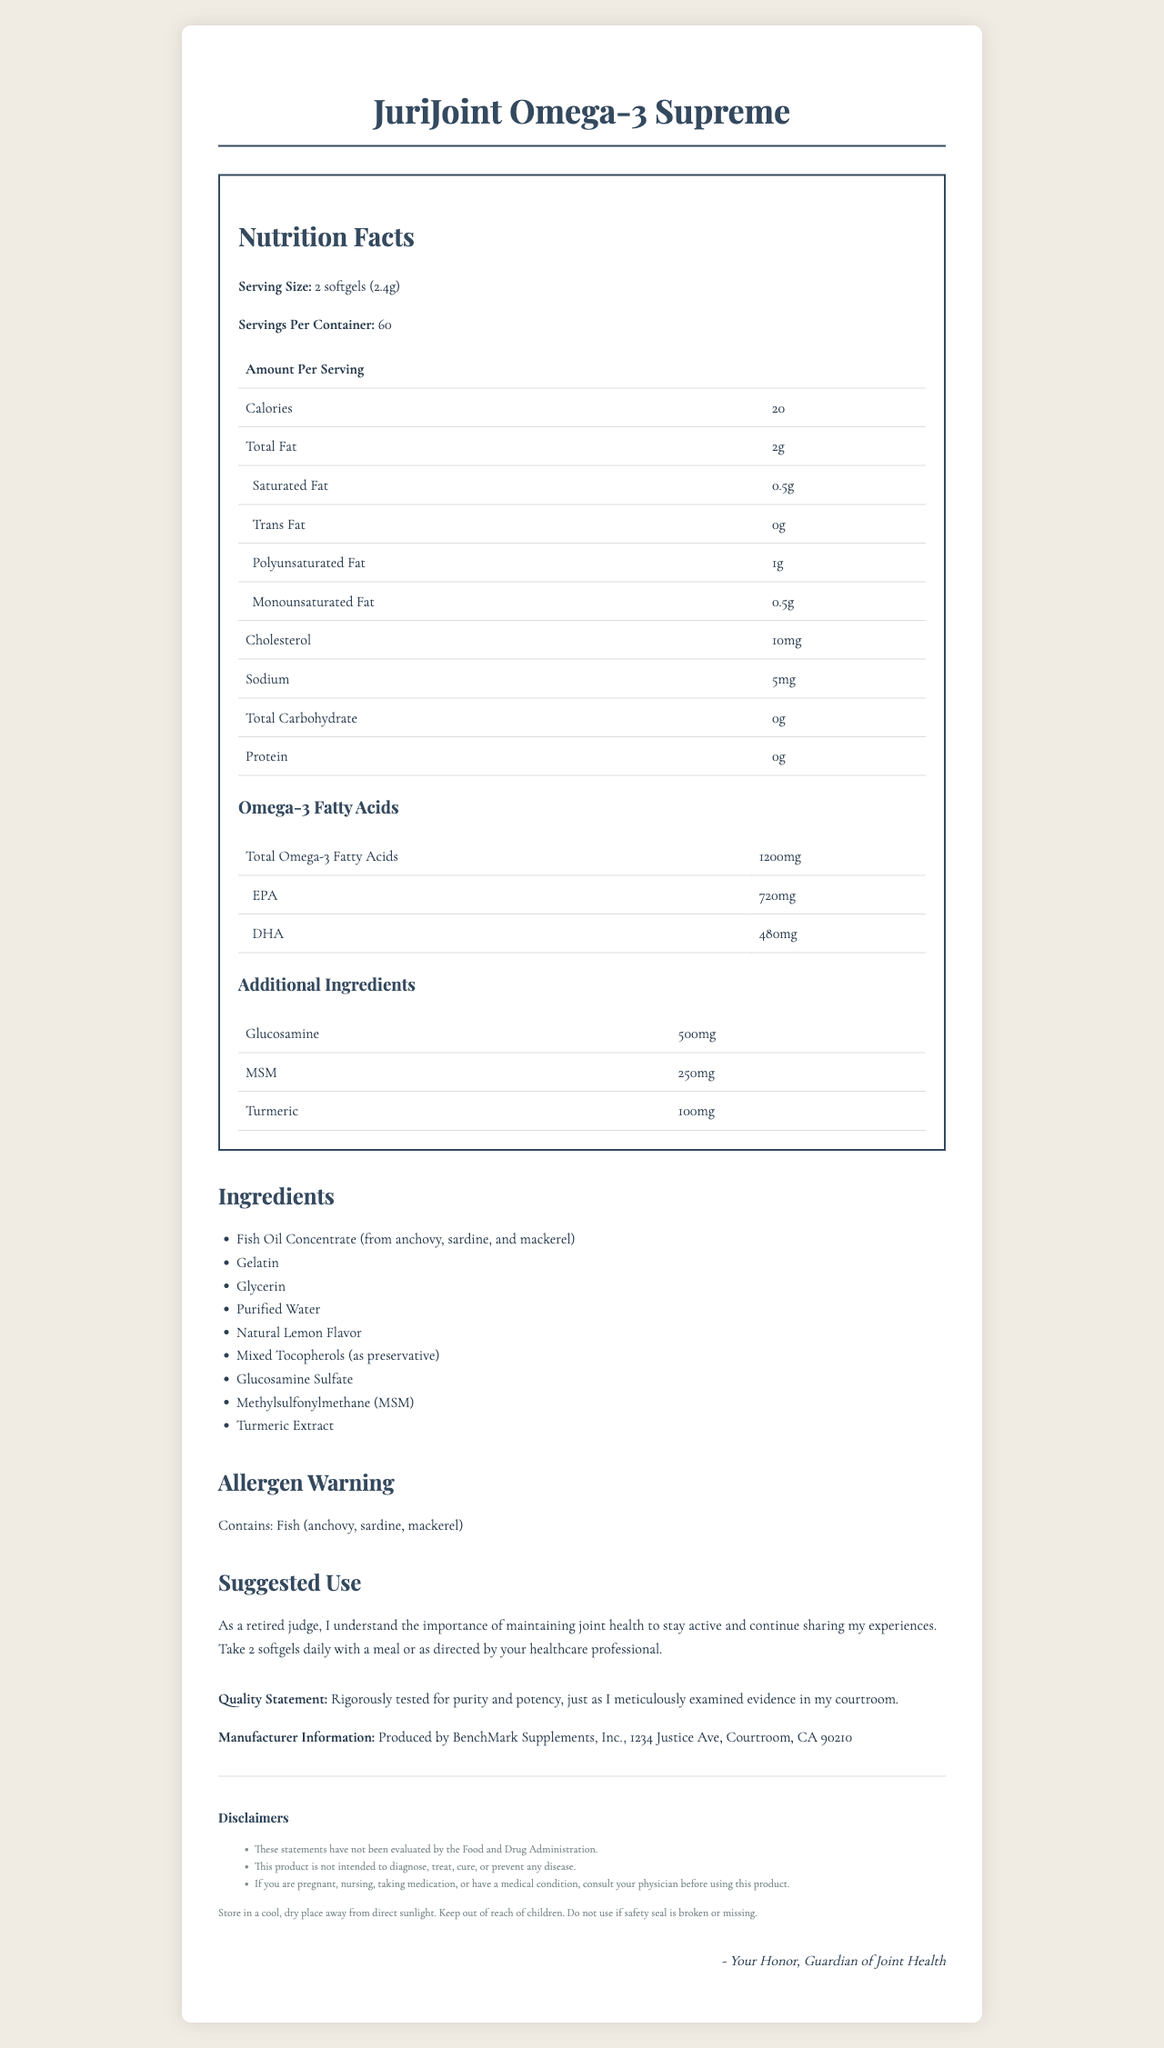what is the serving size? The serving size is mentioned at the beginning of the Nutrition Facts section.
Answer: 2 softgels (2.4g) what allergens are present in this supplement? The allergens are indicated in the "Allergen Warning" section.
Answer: Fish (anchovy, sardine, mackerel) how many calories are in one serving? It is listed under the "Amount Per Serving" in the Nutrition Facts section.
Answer: 20 calories which ingredient is present in the highest amount among omega-3 fatty acids? A. EPA B. DHA C. Other Omega-3s EPA has 720mg, DHA has 480mg, and there is 0mg for other Omega-3s.
Answer: A. EPA what is the suggested usage for this supplement? The suggested usage is clearly stated in the "Suggested Use" section.
Answer: Take 2 softgels daily with a meal or as directed by your healthcare professional. does this product contain any protein? The total protein content is listed as 0g in the Nutrition Facts table.
Answer: No what are the key active ingredients besides omega-3s? Listed in the Additional Ingredients table: Glucosamine (500mg), MSM (250mg), Turmeric (100mg).
Answer: Glucosamine, MSM, Turmeric what is the manufacturer's address? This information is provided in the "Manufacturer Information" section.
Answer: 1234 Justice Ave, Courtroom, CA 90210 which type of fat is present in the lowest amount? A. Saturated Fat B. Monounsaturated Fat C. Polyunsaturated Fat The document lists Saturated Fat as 0.5g, Monounsaturated Fat as 0.5g, and Polyunsaturated Fat as 1g.
Answer: C. Polyunsaturated Fat Are there any carbohydrates in JuriJoint Omega-3 Supreme? Total Carbohydrates is listed as 0g in the Nutrition Facts table.
Answer: No what is the purpose of this supplement? Based on the product name and the ingredients such as omega-3 fatty acids, glucosamine, MSM, and turmeric, the supplement is designed for joint health and reducing inflammation.
Answer: To support joint health and reduce inflammation does the product contain any vitamin D? The Vitamin D content is listed as 0mcg in the Nutrition Facts table.
Answer: No summarize the main idea of the document. The document presents comprehensive nutritional data, ingredient lists, usage instructions, and additional label information for the JuriJoint Omega-3 Supreme supplement, emphasizing its benefits and compliance with quality standards.
Answer: JuriJoint Omega-3 Supreme is a fish oil supplement rich in omega-3 fatty acids, glucosamine, MSM, and turmeric, designed to support joint health and reduce inflammation. It provides detailed nutritional information, ingredients, allergen warnings, suggested usage, and manufacturer details while stressing the product's purity and potency. how many different types of fish are used in the fish oil concentrate? The ingredients list shows that the fish oil concentrate is derived from anchovy, sardine, and mackerel.
Answer: Three does this supplement contain any iron? The iron content is listed as 0mg in the Nutrition Facts table.
Answer: No what does the document say about whether this product can cure diseases? This is stated in the disclaimers section.
Answer: This product is not intended to diagnose, treat, cure, or prevent any disease. what is the exact amount of turmeric in this supplement? The amount is specified in the Additional Ingredients table.
Answer: 100mg how many softgels should be taken daily according to the suggested use? The suggested use section advises taking 2 softgels daily.
Answer: 2 softgels which ingredient serves as a preservative? Listed in the ingredients as “Mixed Tocopherols (as preservative)”.
Answer: Mixed Tocopherols is the product tested for purity and potency? The quality statement indicates that the product is rigorously tested for purity and potency.
Answer: Yes describe the storage instructions given in the document. The storage and legal notes section provides this information.
Answer: Store in a cool, dry place away from direct sunlight. Keep out of reach of children. Do not use if safety seal is broken or missing. what is the epa to dha ratio in the total omega-3 fatty acids? EPA is 720mg and DHA is 480mg, so the ratio is 3:2.
Answer: 3:2 what is the total weight of omega-3s in a daily serving of two softgels? Each serving contains 1200mg of total omega-3s, and the suggested use is to take two softgels daily which equals 2400mg.
Answer: 2400 mg which of the following cannot be determined from the document? A. The exact breakdown of natural lemon flavor B. The exact amount of monounsaturated fat C. The manufacturer's quality standards D. The exact quantity of EPA per serving The document lists “Natural Lemon Flavor” but does not provide a detailed breakdown of its components.
Answer: A. The exact breakdown of natural lemon flavor 